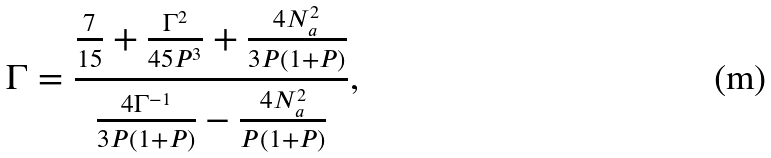<formula> <loc_0><loc_0><loc_500><loc_500>\Gamma = \frac { \frac { 7 } { 1 5 } + \frac { \Gamma ^ { 2 } } { 4 5 P ^ { 3 } } + \frac { 4 N _ { a } ^ { 2 } } { 3 P ( 1 + P ) } } { \frac { 4 \Gamma ^ { - 1 } } { 3 P ( 1 + P ) } - \frac { 4 N _ { a } ^ { 2 } } { P ( 1 + P ) } } ,</formula> 